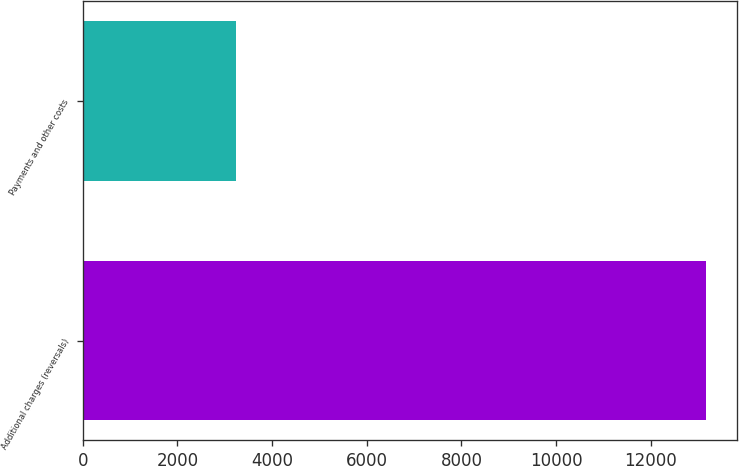<chart> <loc_0><loc_0><loc_500><loc_500><bar_chart><fcel>Additional charges (reversals)<fcel>Payments and other costs<nl><fcel>13172<fcel>3236<nl></chart> 